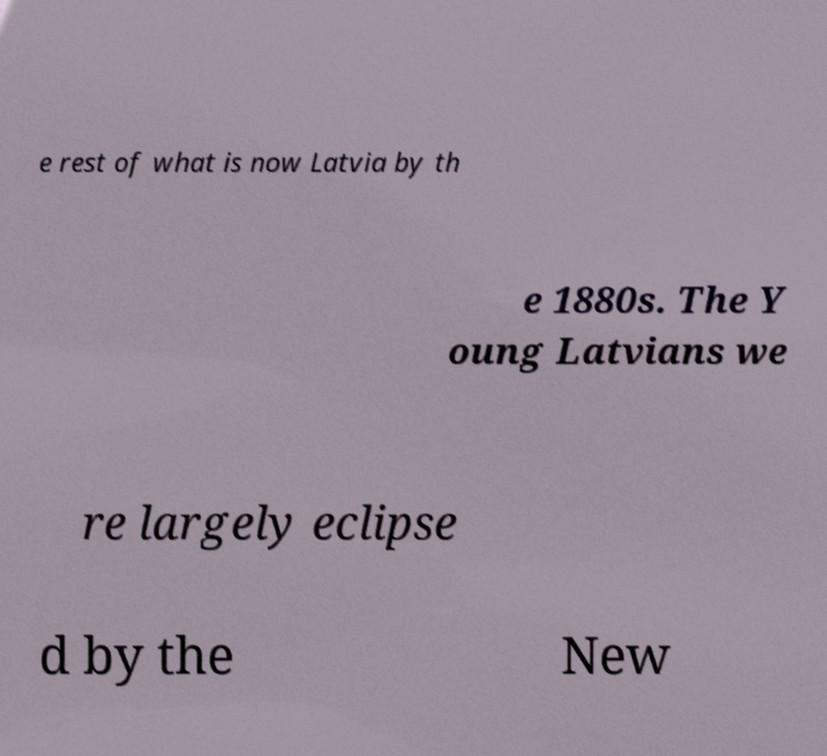There's text embedded in this image that I need extracted. Can you transcribe it verbatim? e rest of what is now Latvia by th e 1880s. The Y oung Latvians we re largely eclipse d by the New 